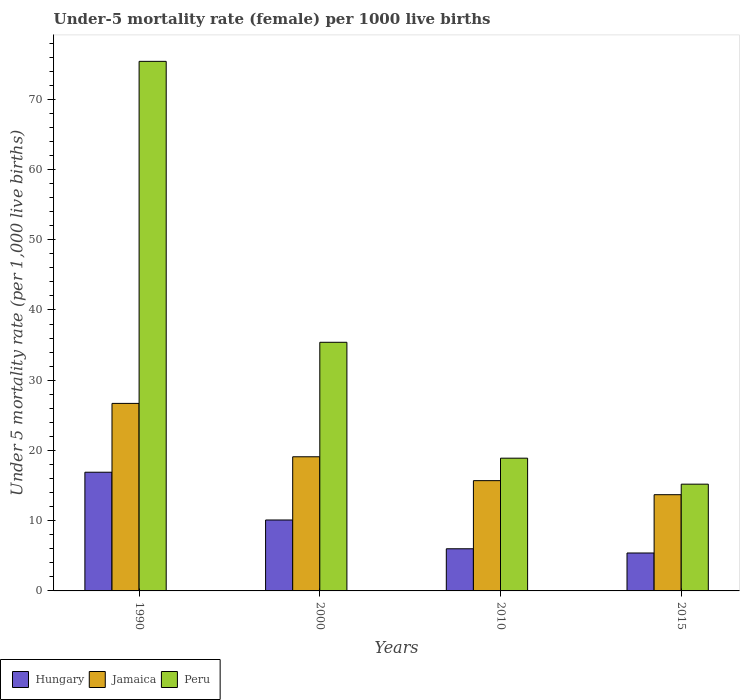How many different coloured bars are there?
Provide a succinct answer. 3. How many groups of bars are there?
Provide a succinct answer. 4. Are the number of bars on each tick of the X-axis equal?
Keep it short and to the point. Yes. How many bars are there on the 4th tick from the left?
Give a very brief answer. 3. How many bars are there on the 1st tick from the right?
Your answer should be compact. 3. What is the label of the 2nd group of bars from the left?
Offer a very short reply. 2000. In how many cases, is the number of bars for a given year not equal to the number of legend labels?
Your response must be concise. 0. What is the under-five mortality rate in Jamaica in 2010?
Provide a succinct answer. 15.7. Across all years, what is the maximum under-five mortality rate in Jamaica?
Ensure brevity in your answer.  26.7. In which year was the under-five mortality rate in Hungary maximum?
Your answer should be very brief. 1990. In which year was the under-five mortality rate in Peru minimum?
Ensure brevity in your answer.  2015. What is the total under-five mortality rate in Hungary in the graph?
Keep it short and to the point. 38.4. What is the difference between the under-five mortality rate in Peru in 2000 and that in 2015?
Give a very brief answer. 20.2. What is the difference between the under-five mortality rate in Jamaica in 2000 and the under-five mortality rate in Peru in 2010?
Provide a succinct answer. 0.2. In the year 1990, what is the difference between the under-five mortality rate in Peru and under-five mortality rate in Jamaica?
Provide a succinct answer. 48.7. What is the ratio of the under-five mortality rate in Hungary in 2010 to that in 2015?
Provide a succinct answer. 1.11. What is the difference between the highest and the second highest under-five mortality rate in Hungary?
Make the answer very short. 6.8. What is the difference between the highest and the lowest under-five mortality rate in Jamaica?
Make the answer very short. 13. In how many years, is the under-five mortality rate in Peru greater than the average under-five mortality rate in Peru taken over all years?
Your response must be concise. 1. What does the 1st bar from the left in 2015 represents?
Make the answer very short. Hungary. Is it the case that in every year, the sum of the under-five mortality rate in Hungary and under-five mortality rate in Peru is greater than the under-five mortality rate in Jamaica?
Offer a terse response. Yes. How many bars are there?
Your response must be concise. 12. How many years are there in the graph?
Offer a terse response. 4. Does the graph contain grids?
Keep it short and to the point. No. Where does the legend appear in the graph?
Your response must be concise. Bottom left. How many legend labels are there?
Keep it short and to the point. 3. What is the title of the graph?
Provide a short and direct response. Under-5 mortality rate (female) per 1000 live births. Does "Armenia" appear as one of the legend labels in the graph?
Provide a short and direct response. No. What is the label or title of the X-axis?
Offer a terse response. Years. What is the label or title of the Y-axis?
Offer a very short reply. Under 5 mortality rate (per 1,0 live births). What is the Under 5 mortality rate (per 1,000 live births) in Hungary in 1990?
Give a very brief answer. 16.9. What is the Under 5 mortality rate (per 1,000 live births) in Jamaica in 1990?
Your answer should be compact. 26.7. What is the Under 5 mortality rate (per 1,000 live births) of Peru in 1990?
Provide a short and direct response. 75.4. What is the Under 5 mortality rate (per 1,000 live births) in Hungary in 2000?
Offer a very short reply. 10.1. What is the Under 5 mortality rate (per 1,000 live births) of Peru in 2000?
Ensure brevity in your answer.  35.4. What is the Under 5 mortality rate (per 1,000 live births) in Jamaica in 2010?
Make the answer very short. 15.7. What is the Under 5 mortality rate (per 1,000 live births) of Jamaica in 2015?
Make the answer very short. 13.7. Across all years, what is the maximum Under 5 mortality rate (per 1,000 live births) in Jamaica?
Provide a short and direct response. 26.7. Across all years, what is the maximum Under 5 mortality rate (per 1,000 live births) in Peru?
Provide a succinct answer. 75.4. Across all years, what is the minimum Under 5 mortality rate (per 1,000 live births) of Hungary?
Offer a terse response. 5.4. Across all years, what is the minimum Under 5 mortality rate (per 1,000 live births) of Jamaica?
Keep it short and to the point. 13.7. What is the total Under 5 mortality rate (per 1,000 live births) of Hungary in the graph?
Keep it short and to the point. 38.4. What is the total Under 5 mortality rate (per 1,000 live births) in Jamaica in the graph?
Keep it short and to the point. 75.2. What is the total Under 5 mortality rate (per 1,000 live births) in Peru in the graph?
Make the answer very short. 144.9. What is the difference between the Under 5 mortality rate (per 1,000 live births) in Jamaica in 1990 and that in 2000?
Your response must be concise. 7.6. What is the difference between the Under 5 mortality rate (per 1,000 live births) of Peru in 1990 and that in 2000?
Give a very brief answer. 40. What is the difference between the Under 5 mortality rate (per 1,000 live births) of Hungary in 1990 and that in 2010?
Your answer should be compact. 10.9. What is the difference between the Under 5 mortality rate (per 1,000 live births) of Peru in 1990 and that in 2010?
Your response must be concise. 56.5. What is the difference between the Under 5 mortality rate (per 1,000 live births) in Hungary in 1990 and that in 2015?
Give a very brief answer. 11.5. What is the difference between the Under 5 mortality rate (per 1,000 live births) of Jamaica in 1990 and that in 2015?
Provide a short and direct response. 13. What is the difference between the Under 5 mortality rate (per 1,000 live births) in Peru in 1990 and that in 2015?
Provide a succinct answer. 60.2. What is the difference between the Under 5 mortality rate (per 1,000 live births) of Hungary in 2000 and that in 2010?
Provide a short and direct response. 4.1. What is the difference between the Under 5 mortality rate (per 1,000 live births) of Jamaica in 2000 and that in 2010?
Give a very brief answer. 3.4. What is the difference between the Under 5 mortality rate (per 1,000 live births) in Peru in 2000 and that in 2010?
Keep it short and to the point. 16.5. What is the difference between the Under 5 mortality rate (per 1,000 live births) in Jamaica in 2000 and that in 2015?
Your response must be concise. 5.4. What is the difference between the Under 5 mortality rate (per 1,000 live births) of Peru in 2000 and that in 2015?
Make the answer very short. 20.2. What is the difference between the Under 5 mortality rate (per 1,000 live births) in Hungary in 2010 and that in 2015?
Offer a terse response. 0.6. What is the difference between the Under 5 mortality rate (per 1,000 live births) of Hungary in 1990 and the Under 5 mortality rate (per 1,000 live births) of Jamaica in 2000?
Provide a succinct answer. -2.2. What is the difference between the Under 5 mortality rate (per 1,000 live births) of Hungary in 1990 and the Under 5 mortality rate (per 1,000 live births) of Peru in 2000?
Provide a succinct answer. -18.5. What is the difference between the Under 5 mortality rate (per 1,000 live births) in Jamaica in 1990 and the Under 5 mortality rate (per 1,000 live births) in Peru in 2000?
Provide a short and direct response. -8.7. What is the difference between the Under 5 mortality rate (per 1,000 live births) in Jamaica in 1990 and the Under 5 mortality rate (per 1,000 live births) in Peru in 2010?
Make the answer very short. 7.8. What is the difference between the Under 5 mortality rate (per 1,000 live births) in Hungary in 1990 and the Under 5 mortality rate (per 1,000 live births) in Jamaica in 2015?
Ensure brevity in your answer.  3.2. What is the difference between the Under 5 mortality rate (per 1,000 live births) of Hungary in 1990 and the Under 5 mortality rate (per 1,000 live births) of Peru in 2015?
Make the answer very short. 1.7. What is the difference between the Under 5 mortality rate (per 1,000 live births) in Jamaica in 1990 and the Under 5 mortality rate (per 1,000 live births) in Peru in 2015?
Keep it short and to the point. 11.5. What is the difference between the Under 5 mortality rate (per 1,000 live births) of Hungary in 2000 and the Under 5 mortality rate (per 1,000 live births) of Peru in 2010?
Ensure brevity in your answer.  -8.8. What is the difference between the Under 5 mortality rate (per 1,000 live births) in Jamaica in 2000 and the Under 5 mortality rate (per 1,000 live births) in Peru in 2015?
Your response must be concise. 3.9. What is the difference between the Under 5 mortality rate (per 1,000 live births) in Hungary in 2010 and the Under 5 mortality rate (per 1,000 live births) in Jamaica in 2015?
Offer a very short reply. -7.7. What is the difference between the Under 5 mortality rate (per 1,000 live births) of Hungary in 2010 and the Under 5 mortality rate (per 1,000 live births) of Peru in 2015?
Your response must be concise. -9.2. What is the average Under 5 mortality rate (per 1,000 live births) in Jamaica per year?
Provide a short and direct response. 18.8. What is the average Under 5 mortality rate (per 1,000 live births) in Peru per year?
Make the answer very short. 36.23. In the year 1990, what is the difference between the Under 5 mortality rate (per 1,000 live births) of Hungary and Under 5 mortality rate (per 1,000 live births) of Peru?
Offer a terse response. -58.5. In the year 1990, what is the difference between the Under 5 mortality rate (per 1,000 live births) in Jamaica and Under 5 mortality rate (per 1,000 live births) in Peru?
Your answer should be compact. -48.7. In the year 2000, what is the difference between the Under 5 mortality rate (per 1,000 live births) of Hungary and Under 5 mortality rate (per 1,000 live births) of Peru?
Your answer should be compact. -25.3. In the year 2000, what is the difference between the Under 5 mortality rate (per 1,000 live births) in Jamaica and Under 5 mortality rate (per 1,000 live births) in Peru?
Offer a very short reply. -16.3. In the year 2010, what is the difference between the Under 5 mortality rate (per 1,000 live births) in Hungary and Under 5 mortality rate (per 1,000 live births) in Jamaica?
Provide a succinct answer. -9.7. In the year 2010, what is the difference between the Under 5 mortality rate (per 1,000 live births) of Hungary and Under 5 mortality rate (per 1,000 live births) of Peru?
Provide a succinct answer. -12.9. In the year 2015, what is the difference between the Under 5 mortality rate (per 1,000 live births) in Hungary and Under 5 mortality rate (per 1,000 live births) in Jamaica?
Provide a succinct answer. -8.3. In the year 2015, what is the difference between the Under 5 mortality rate (per 1,000 live births) in Jamaica and Under 5 mortality rate (per 1,000 live births) in Peru?
Ensure brevity in your answer.  -1.5. What is the ratio of the Under 5 mortality rate (per 1,000 live births) of Hungary in 1990 to that in 2000?
Provide a succinct answer. 1.67. What is the ratio of the Under 5 mortality rate (per 1,000 live births) in Jamaica in 1990 to that in 2000?
Your response must be concise. 1.4. What is the ratio of the Under 5 mortality rate (per 1,000 live births) of Peru in 1990 to that in 2000?
Your answer should be compact. 2.13. What is the ratio of the Under 5 mortality rate (per 1,000 live births) in Hungary in 1990 to that in 2010?
Provide a short and direct response. 2.82. What is the ratio of the Under 5 mortality rate (per 1,000 live births) in Jamaica in 1990 to that in 2010?
Offer a terse response. 1.7. What is the ratio of the Under 5 mortality rate (per 1,000 live births) of Peru in 1990 to that in 2010?
Make the answer very short. 3.99. What is the ratio of the Under 5 mortality rate (per 1,000 live births) in Hungary in 1990 to that in 2015?
Your answer should be compact. 3.13. What is the ratio of the Under 5 mortality rate (per 1,000 live births) of Jamaica in 1990 to that in 2015?
Give a very brief answer. 1.95. What is the ratio of the Under 5 mortality rate (per 1,000 live births) of Peru in 1990 to that in 2015?
Ensure brevity in your answer.  4.96. What is the ratio of the Under 5 mortality rate (per 1,000 live births) of Hungary in 2000 to that in 2010?
Offer a very short reply. 1.68. What is the ratio of the Under 5 mortality rate (per 1,000 live births) of Jamaica in 2000 to that in 2010?
Keep it short and to the point. 1.22. What is the ratio of the Under 5 mortality rate (per 1,000 live births) of Peru in 2000 to that in 2010?
Ensure brevity in your answer.  1.87. What is the ratio of the Under 5 mortality rate (per 1,000 live births) in Hungary in 2000 to that in 2015?
Offer a very short reply. 1.87. What is the ratio of the Under 5 mortality rate (per 1,000 live births) of Jamaica in 2000 to that in 2015?
Provide a short and direct response. 1.39. What is the ratio of the Under 5 mortality rate (per 1,000 live births) of Peru in 2000 to that in 2015?
Your answer should be very brief. 2.33. What is the ratio of the Under 5 mortality rate (per 1,000 live births) in Hungary in 2010 to that in 2015?
Your response must be concise. 1.11. What is the ratio of the Under 5 mortality rate (per 1,000 live births) in Jamaica in 2010 to that in 2015?
Provide a succinct answer. 1.15. What is the ratio of the Under 5 mortality rate (per 1,000 live births) of Peru in 2010 to that in 2015?
Give a very brief answer. 1.24. What is the difference between the highest and the second highest Under 5 mortality rate (per 1,000 live births) of Jamaica?
Offer a very short reply. 7.6. What is the difference between the highest and the lowest Under 5 mortality rate (per 1,000 live births) in Peru?
Make the answer very short. 60.2. 